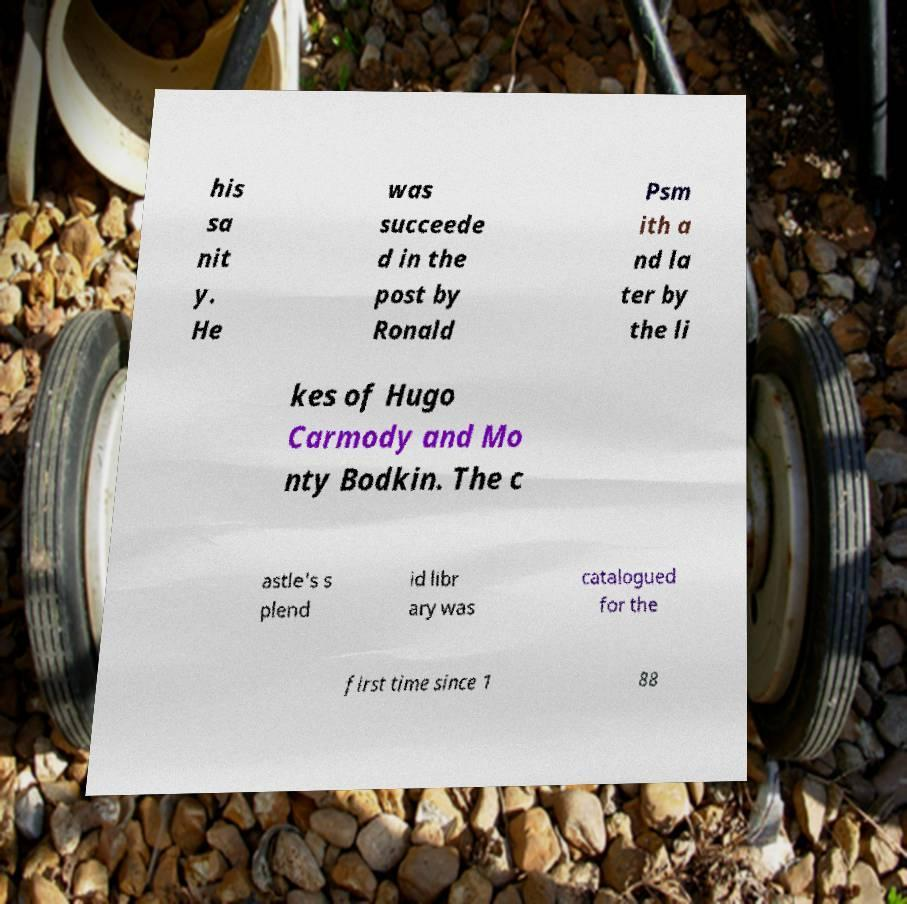Can you read and provide the text displayed in the image?This photo seems to have some interesting text. Can you extract and type it out for me? his sa nit y. He was succeede d in the post by Ronald Psm ith a nd la ter by the li kes of Hugo Carmody and Mo nty Bodkin. The c astle's s plend id libr ary was catalogued for the first time since 1 88 